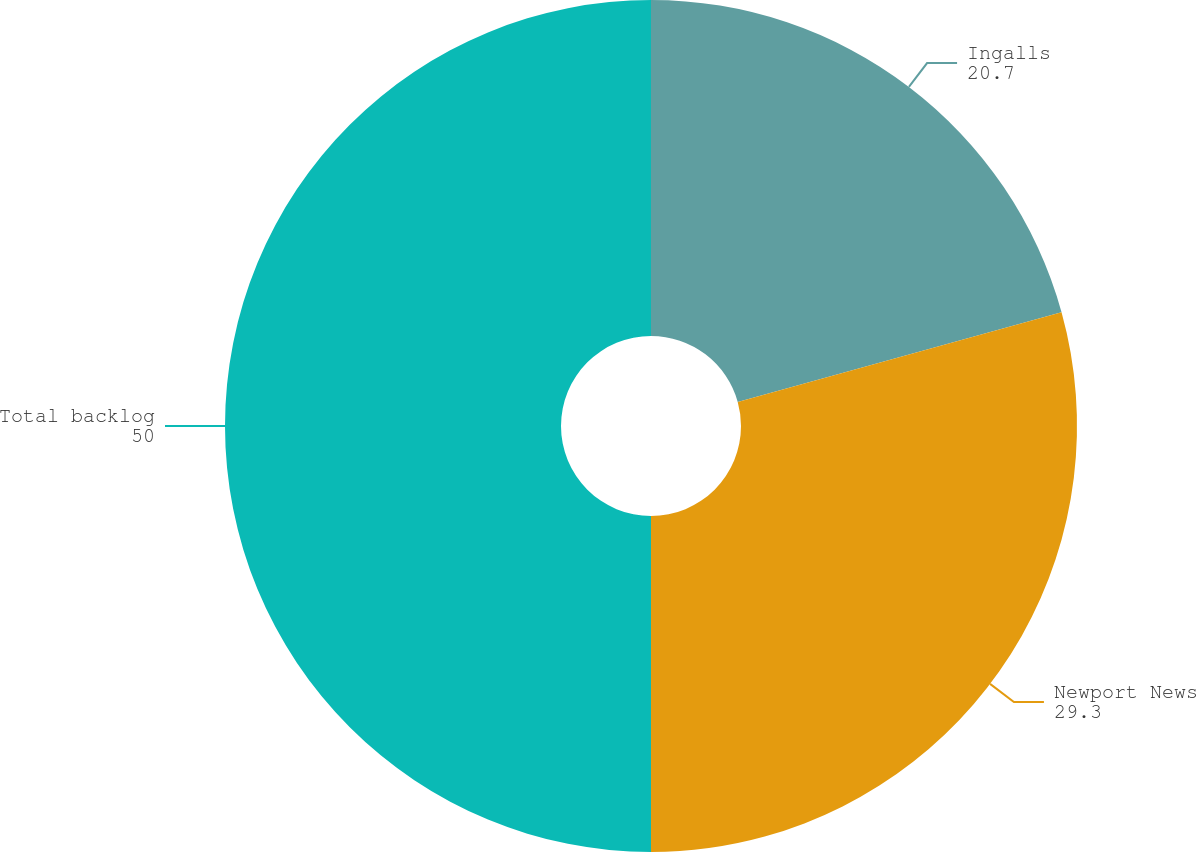<chart> <loc_0><loc_0><loc_500><loc_500><pie_chart><fcel>Ingalls<fcel>Newport News<fcel>Total backlog<nl><fcel>20.7%<fcel>29.3%<fcel>50.0%<nl></chart> 